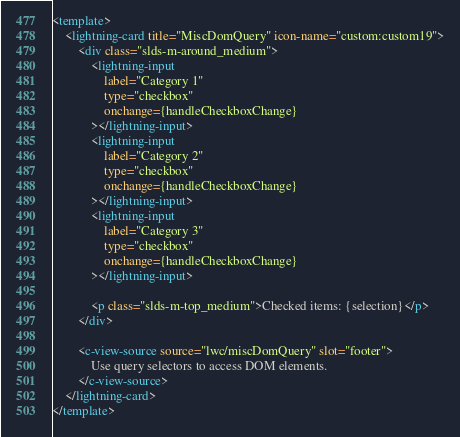<code> <loc_0><loc_0><loc_500><loc_500><_HTML_><template>
    <lightning-card title="MiscDomQuery" icon-name="custom:custom19">
        <div class="slds-m-around_medium">
            <lightning-input
                label="Category 1"
                type="checkbox"
                onchange={handleCheckboxChange}
            ></lightning-input>
            <lightning-input
                label="Category 2"
                type="checkbox"
                onchange={handleCheckboxChange}
            ></lightning-input>
            <lightning-input
                label="Category 3"
                type="checkbox"
                onchange={handleCheckboxChange}
            ></lightning-input>

            <p class="slds-m-top_medium">Checked items: {selection}</p>
        </div>

        <c-view-source source="lwc/miscDomQuery" slot="footer">
            Use query selectors to access DOM elements.
        </c-view-source>
    </lightning-card>
</template>
</code> 